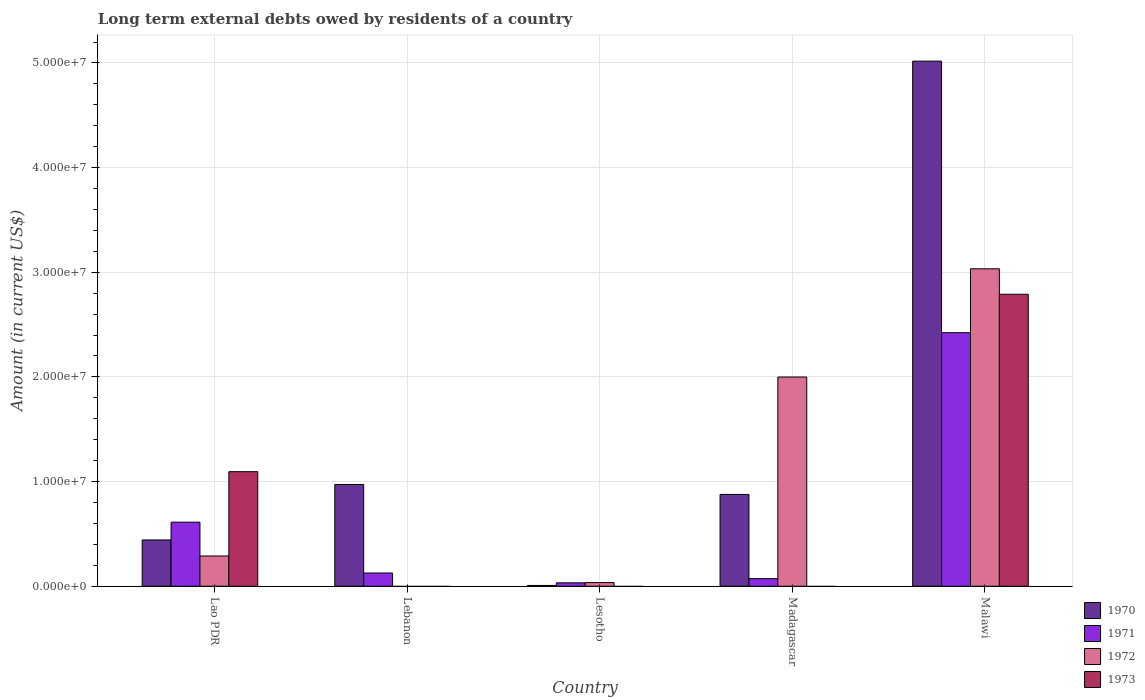How many groups of bars are there?
Your answer should be very brief. 5. Are the number of bars on each tick of the X-axis equal?
Provide a succinct answer. No. How many bars are there on the 2nd tick from the left?
Provide a short and direct response. 2. What is the label of the 1st group of bars from the left?
Your answer should be very brief. Lao PDR. In how many cases, is the number of bars for a given country not equal to the number of legend labels?
Offer a very short reply. 3. What is the amount of long-term external debts owed by residents in 1970 in Malawi?
Your answer should be very brief. 5.02e+07. Across all countries, what is the maximum amount of long-term external debts owed by residents in 1971?
Your answer should be very brief. 2.42e+07. Across all countries, what is the minimum amount of long-term external debts owed by residents in 1971?
Offer a very short reply. 3.26e+05. In which country was the amount of long-term external debts owed by residents in 1971 maximum?
Your answer should be very brief. Malawi. What is the total amount of long-term external debts owed by residents in 1970 in the graph?
Provide a short and direct response. 7.32e+07. What is the difference between the amount of long-term external debts owed by residents in 1973 in Lao PDR and that in Malawi?
Ensure brevity in your answer.  -1.70e+07. What is the difference between the amount of long-term external debts owed by residents in 1970 in Malawi and the amount of long-term external debts owed by residents in 1972 in Lesotho?
Your response must be concise. 4.98e+07. What is the average amount of long-term external debts owed by residents in 1972 per country?
Offer a very short reply. 1.07e+07. What is the difference between the amount of long-term external debts owed by residents of/in 1973 and amount of long-term external debts owed by residents of/in 1972 in Lao PDR?
Provide a short and direct response. 8.06e+06. In how many countries, is the amount of long-term external debts owed by residents in 1972 greater than 28000000 US$?
Your response must be concise. 1. What is the ratio of the amount of long-term external debts owed by residents in 1971 in Lao PDR to that in Lesotho?
Offer a very short reply. 18.79. Is the amount of long-term external debts owed by residents in 1970 in Lesotho less than that in Madagascar?
Provide a short and direct response. Yes. What is the difference between the highest and the second highest amount of long-term external debts owed by residents in 1971?
Offer a very short reply. 2.30e+07. What is the difference between the highest and the lowest amount of long-term external debts owed by residents in 1970?
Ensure brevity in your answer.  5.01e+07. In how many countries, is the amount of long-term external debts owed by residents in 1970 greater than the average amount of long-term external debts owed by residents in 1970 taken over all countries?
Your response must be concise. 1. Is the sum of the amount of long-term external debts owed by residents in 1971 in Lesotho and Madagascar greater than the maximum amount of long-term external debts owed by residents in 1972 across all countries?
Provide a short and direct response. No. Is it the case that in every country, the sum of the amount of long-term external debts owed by residents in 1970 and amount of long-term external debts owed by residents in 1973 is greater than the sum of amount of long-term external debts owed by residents in 1972 and amount of long-term external debts owed by residents in 1971?
Offer a terse response. No. Is it the case that in every country, the sum of the amount of long-term external debts owed by residents in 1972 and amount of long-term external debts owed by residents in 1970 is greater than the amount of long-term external debts owed by residents in 1971?
Make the answer very short. Yes. How many bars are there?
Your answer should be very brief. 16. Are all the bars in the graph horizontal?
Your answer should be very brief. No. Does the graph contain grids?
Your answer should be compact. Yes. Where does the legend appear in the graph?
Make the answer very short. Bottom right. What is the title of the graph?
Your response must be concise. Long term external debts owed by residents of a country. What is the Amount (in current US$) of 1970 in Lao PDR?
Offer a terse response. 4.42e+06. What is the Amount (in current US$) of 1971 in Lao PDR?
Give a very brief answer. 6.12e+06. What is the Amount (in current US$) in 1972 in Lao PDR?
Provide a succinct answer. 2.89e+06. What is the Amount (in current US$) of 1973 in Lao PDR?
Offer a terse response. 1.09e+07. What is the Amount (in current US$) in 1970 in Lebanon?
Give a very brief answer. 9.73e+06. What is the Amount (in current US$) of 1971 in Lebanon?
Provide a succinct answer. 1.26e+06. What is the Amount (in current US$) in 1972 in Lebanon?
Give a very brief answer. 0. What is the Amount (in current US$) in 1973 in Lebanon?
Ensure brevity in your answer.  0. What is the Amount (in current US$) in 1970 in Lesotho?
Ensure brevity in your answer.  7.60e+04. What is the Amount (in current US$) in 1971 in Lesotho?
Provide a short and direct response. 3.26e+05. What is the Amount (in current US$) in 1972 in Lesotho?
Offer a very short reply. 3.48e+05. What is the Amount (in current US$) in 1970 in Madagascar?
Your response must be concise. 8.78e+06. What is the Amount (in current US$) of 1971 in Madagascar?
Your answer should be very brief. 7.30e+05. What is the Amount (in current US$) of 1972 in Madagascar?
Provide a short and direct response. 2.00e+07. What is the Amount (in current US$) in 1973 in Madagascar?
Ensure brevity in your answer.  0. What is the Amount (in current US$) in 1970 in Malawi?
Your answer should be compact. 5.02e+07. What is the Amount (in current US$) in 1971 in Malawi?
Offer a very short reply. 2.42e+07. What is the Amount (in current US$) of 1972 in Malawi?
Keep it short and to the point. 3.03e+07. What is the Amount (in current US$) of 1973 in Malawi?
Your answer should be very brief. 2.79e+07. Across all countries, what is the maximum Amount (in current US$) in 1970?
Give a very brief answer. 5.02e+07. Across all countries, what is the maximum Amount (in current US$) in 1971?
Keep it short and to the point. 2.42e+07. Across all countries, what is the maximum Amount (in current US$) in 1972?
Offer a terse response. 3.03e+07. Across all countries, what is the maximum Amount (in current US$) in 1973?
Provide a succinct answer. 2.79e+07. Across all countries, what is the minimum Amount (in current US$) of 1970?
Make the answer very short. 7.60e+04. Across all countries, what is the minimum Amount (in current US$) in 1971?
Offer a very short reply. 3.26e+05. Across all countries, what is the minimum Amount (in current US$) of 1972?
Ensure brevity in your answer.  0. What is the total Amount (in current US$) of 1970 in the graph?
Give a very brief answer. 7.32e+07. What is the total Amount (in current US$) of 1971 in the graph?
Provide a short and direct response. 3.27e+07. What is the total Amount (in current US$) of 1972 in the graph?
Keep it short and to the point. 5.36e+07. What is the total Amount (in current US$) of 1973 in the graph?
Your answer should be very brief. 3.88e+07. What is the difference between the Amount (in current US$) in 1970 in Lao PDR and that in Lebanon?
Provide a succinct answer. -5.30e+06. What is the difference between the Amount (in current US$) of 1971 in Lao PDR and that in Lebanon?
Offer a very short reply. 4.86e+06. What is the difference between the Amount (in current US$) of 1970 in Lao PDR and that in Lesotho?
Provide a succinct answer. 4.35e+06. What is the difference between the Amount (in current US$) in 1971 in Lao PDR and that in Lesotho?
Keep it short and to the point. 5.80e+06. What is the difference between the Amount (in current US$) in 1972 in Lao PDR and that in Lesotho?
Make the answer very short. 2.54e+06. What is the difference between the Amount (in current US$) in 1970 in Lao PDR and that in Madagascar?
Provide a succinct answer. -4.35e+06. What is the difference between the Amount (in current US$) of 1971 in Lao PDR and that in Madagascar?
Your response must be concise. 5.39e+06. What is the difference between the Amount (in current US$) of 1972 in Lao PDR and that in Madagascar?
Offer a very short reply. -1.71e+07. What is the difference between the Amount (in current US$) in 1970 in Lao PDR and that in Malawi?
Ensure brevity in your answer.  -4.58e+07. What is the difference between the Amount (in current US$) of 1971 in Lao PDR and that in Malawi?
Make the answer very short. -1.81e+07. What is the difference between the Amount (in current US$) of 1972 in Lao PDR and that in Malawi?
Offer a terse response. -2.74e+07. What is the difference between the Amount (in current US$) of 1973 in Lao PDR and that in Malawi?
Your answer should be compact. -1.70e+07. What is the difference between the Amount (in current US$) in 1970 in Lebanon and that in Lesotho?
Keep it short and to the point. 9.65e+06. What is the difference between the Amount (in current US$) of 1971 in Lebanon and that in Lesotho?
Keep it short and to the point. 9.39e+05. What is the difference between the Amount (in current US$) of 1970 in Lebanon and that in Madagascar?
Offer a very short reply. 9.51e+05. What is the difference between the Amount (in current US$) of 1971 in Lebanon and that in Madagascar?
Provide a succinct answer. 5.35e+05. What is the difference between the Amount (in current US$) of 1970 in Lebanon and that in Malawi?
Your response must be concise. -4.04e+07. What is the difference between the Amount (in current US$) of 1971 in Lebanon and that in Malawi?
Your response must be concise. -2.30e+07. What is the difference between the Amount (in current US$) in 1970 in Lesotho and that in Madagascar?
Offer a terse response. -8.70e+06. What is the difference between the Amount (in current US$) of 1971 in Lesotho and that in Madagascar?
Offer a very short reply. -4.04e+05. What is the difference between the Amount (in current US$) of 1972 in Lesotho and that in Madagascar?
Your response must be concise. -1.96e+07. What is the difference between the Amount (in current US$) of 1970 in Lesotho and that in Malawi?
Ensure brevity in your answer.  -5.01e+07. What is the difference between the Amount (in current US$) of 1971 in Lesotho and that in Malawi?
Give a very brief answer. -2.39e+07. What is the difference between the Amount (in current US$) of 1972 in Lesotho and that in Malawi?
Your response must be concise. -3.00e+07. What is the difference between the Amount (in current US$) of 1970 in Madagascar and that in Malawi?
Offer a terse response. -4.14e+07. What is the difference between the Amount (in current US$) of 1971 in Madagascar and that in Malawi?
Give a very brief answer. -2.35e+07. What is the difference between the Amount (in current US$) in 1972 in Madagascar and that in Malawi?
Your answer should be compact. -1.03e+07. What is the difference between the Amount (in current US$) in 1970 in Lao PDR and the Amount (in current US$) in 1971 in Lebanon?
Your response must be concise. 3.16e+06. What is the difference between the Amount (in current US$) in 1970 in Lao PDR and the Amount (in current US$) in 1971 in Lesotho?
Your answer should be very brief. 4.10e+06. What is the difference between the Amount (in current US$) in 1970 in Lao PDR and the Amount (in current US$) in 1972 in Lesotho?
Offer a terse response. 4.08e+06. What is the difference between the Amount (in current US$) of 1971 in Lao PDR and the Amount (in current US$) of 1972 in Lesotho?
Offer a very short reply. 5.78e+06. What is the difference between the Amount (in current US$) in 1970 in Lao PDR and the Amount (in current US$) in 1971 in Madagascar?
Make the answer very short. 3.69e+06. What is the difference between the Amount (in current US$) of 1970 in Lao PDR and the Amount (in current US$) of 1972 in Madagascar?
Offer a very short reply. -1.56e+07. What is the difference between the Amount (in current US$) of 1971 in Lao PDR and the Amount (in current US$) of 1972 in Madagascar?
Your response must be concise. -1.39e+07. What is the difference between the Amount (in current US$) in 1970 in Lao PDR and the Amount (in current US$) in 1971 in Malawi?
Make the answer very short. -1.98e+07. What is the difference between the Amount (in current US$) of 1970 in Lao PDR and the Amount (in current US$) of 1972 in Malawi?
Offer a terse response. -2.59e+07. What is the difference between the Amount (in current US$) in 1970 in Lao PDR and the Amount (in current US$) in 1973 in Malawi?
Your response must be concise. -2.35e+07. What is the difference between the Amount (in current US$) of 1971 in Lao PDR and the Amount (in current US$) of 1972 in Malawi?
Your answer should be very brief. -2.42e+07. What is the difference between the Amount (in current US$) in 1971 in Lao PDR and the Amount (in current US$) in 1973 in Malawi?
Ensure brevity in your answer.  -2.18e+07. What is the difference between the Amount (in current US$) of 1972 in Lao PDR and the Amount (in current US$) of 1973 in Malawi?
Provide a succinct answer. -2.50e+07. What is the difference between the Amount (in current US$) in 1970 in Lebanon and the Amount (in current US$) in 1971 in Lesotho?
Provide a succinct answer. 9.40e+06. What is the difference between the Amount (in current US$) in 1970 in Lebanon and the Amount (in current US$) in 1972 in Lesotho?
Offer a very short reply. 9.38e+06. What is the difference between the Amount (in current US$) of 1971 in Lebanon and the Amount (in current US$) of 1972 in Lesotho?
Offer a terse response. 9.17e+05. What is the difference between the Amount (in current US$) in 1970 in Lebanon and the Amount (in current US$) in 1971 in Madagascar?
Keep it short and to the point. 9.00e+06. What is the difference between the Amount (in current US$) in 1970 in Lebanon and the Amount (in current US$) in 1972 in Madagascar?
Keep it short and to the point. -1.03e+07. What is the difference between the Amount (in current US$) in 1971 in Lebanon and the Amount (in current US$) in 1972 in Madagascar?
Make the answer very short. -1.87e+07. What is the difference between the Amount (in current US$) in 1970 in Lebanon and the Amount (in current US$) in 1971 in Malawi?
Provide a succinct answer. -1.45e+07. What is the difference between the Amount (in current US$) of 1970 in Lebanon and the Amount (in current US$) of 1972 in Malawi?
Ensure brevity in your answer.  -2.06e+07. What is the difference between the Amount (in current US$) in 1970 in Lebanon and the Amount (in current US$) in 1973 in Malawi?
Offer a very short reply. -1.82e+07. What is the difference between the Amount (in current US$) in 1971 in Lebanon and the Amount (in current US$) in 1972 in Malawi?
Give a very brief answer. -2.91e+07. What is the difference between the Amount (in current US$) in 1971 in Lebanon and the Amount (in current US$) in 1973 in Malawi?
Keep it short and to the point. -2.66e+07. What is the difference between the Amount (in current US$) in 1970 in Lesotho and the Amount (in current US$) in 1971 in Madagascar?
Your response must be concise. -6.54e+05. What is the difference between the Amount (in current US$) in 1970 in Lesotho and the Amount (in current US$) in 1972 in Madagascar?
Provide a short and direct response. -1.99e+07. What is the difference between the Amount (in current US$) in 1971 in Lesotho and the Amount (in current US$) in 1972 in Madagascar?
Your response must be concise. -1.97e+07. What is the difference between the Amount (in current US$) in 1970 in Lesotho and the Amount (in current US$) in 1971 in Malawi?
Make the answer very short. -2.42e+07. What is the difference between the Amount (in current US$) in 1970 in Lesotho and the Amount (in current US$) in 1972 in Malawi?
Ensure brevity in your answer.  -3.03e+07. What is the difference between the Amount (in current US$) in 1970 in Lesotho and the Amount (in current US$) in 1973 in Malawi?
Offer a very short reply. -2.78e+07. What is the difference between the Amount (in current US$) of 1971 in Lesotho and the Amount (in current US$) of 1972 in Malawi?
Give a very brief answer. -3.00e+07. What is the difference between the Amount (in current US$) in 1971 in Lesotho and the Amount (in current US$) in 1973 in Malawi?
Provide a short and direct response. -2.76e+07. What is the difference between the Amount (in current US$) of 1972 in Lesotho and the Amount (in current US$) of 1973 in Malawi?
Ensure brevity in your answer.  -2.76e+07. What is the difference between the Amount (in current US$) of 1970 in Madagascar and the Amount (in current US$) of 1971 in Malawi?
Your answer should be compact. -1.55e+07. What is the difference between the Amount (in current US$) of 1970 in Madagascar and the Amount (in current US$) of 1972 in Malawi?
Your answer should be compact. -2.16e+07. What is the difference between the Amount (in current US$) in 1970 in Madagascar and the Amount (in current US$) in 1973 in Malawi?
Provide a succinct answer. -1.91e+07. What is the difference between the Amount (in current US$) of 1971 in Madagascar and the Amount (in current US$) of 1972 in Malawi?
Your answer should be compact. -2.96e+07. What is the difference between the Amount (in current US$) of 1971 in Madagascar and the Amount (in current US$) of 1973 in Malawi?
Your answer should be very brief. -2.72e+07. What is the difference between the Amount (in current US$) of 1972 in Madagascar and the Amount (in current US$) of 1973 in Malawi?
Offer a terse response. -7.91e+06. What is the average Amount (in current US$) in 1970 per country?
Offer a terse response. 1.46e+07. What is the average Amount (in current US$) in 1971 per country?
Provide a succinct answer. 6.53e+06. What is the average Amount (in current US$) in 1972 per country?
Your answer should be very brief. 1.07e+07. What is the average Amount (in current US$) in 1973 per country?
Your answer should be compact. 7.77e+06. What is the difference between the Amount (in current US$) of 1970 and Amount (in current US$) of 1971 in Lao PDR?
Provide a succinct answer. -1.70e+06. What is the difference between the Amount (in current US$) of 1970 and Amount (in current US$) of 1972 in Lao PDR?
Offer a terse response. 1.53e+06. What is the difference between the Amount (in current US$) of 1970 and Amount (in current US$) of 1973 in Lao PDR?
Your answer should be very brief. -6.52e+06. What is the difference between the Amount (in current US$) in 1971 and Amount (in current US$) in 1972 in Lao PDR?
Your response must be concise. 3.23e+06. What is the difference between the Amount (in current US$) of 1971 and Amount (in current US$) of 1973 in Lao PDR?
Provide a succinct answer. -4.82e+06. What is the difference between the Amount (in current US$) in 1972 and Amount (in current US$) in 1973 in Lao PDR?
Ensure brevity in your answer.  -8.06e+06. What is the difference between the Amount (in current US$) in 1970 and Amount (in current US$) in 1971 in Lebanon?
Offer a terse response. 8.46e+06. What is the difference between the Amount (in current US$) of 1970 and Amount (in current US$) of 1971 in Lesotho?
Give a very brief answer. -2.50e+05. What is the difference between the Amount (in current US$) of 1970 and Amount (in current US$) of 1972 in Lesotho?
Your response must be concise. -2.72e+05. What is the difference between the Amount (in current US$) in 1971 and Amount (in current US$) in 1972 in Lesotho?
Provide a succinct answer. -2.20e+04. What is the difference between the Amount (in current US$) of 1970 and Amount (in current US$) of 1971 in Madagascar?
Your answer should be compact. 8.04e+06. What is the difference between the Amount (in current US$) of 1970 and Amount (in current US$) of 1972 in Madagascar?
Provide a succinct answer. -1.12e+07. What is the difference between the Amount (in current US$) of 1971 and Amount (in current US$) of 1972 in Madagascar?
Your answer should be very brief. -1.93e+07. What is the difference between the Amount (in current US$) in 1970 and Amount (in current US$) in 1971 in Malawi?
Ensure brevity in your answer.  2.59e+07. What is the difference between the Amount (in current US$) in 1970 and Amount (in current US$) in 1972 in Malawi?
Your response must be concise. 1.98e+07. What is the difference between the Amount (in current US$) in 1970 and Amount (in current US$) in 1973 in Malawi?
Provide a succinct answer. 2.23e+07. What is the difference between the Amount (in current US$) in 1971 and Amount (in current US$) in 1972 in Malawi?
Your response must be concise. -6.11e+06. What is the difference between the Amount (in current US$) in 1971 and Amount (in current US$) in 1973 in Malawi?
Offer a very short reply. -3.67e+06. What is the difference between the Amount (in current US$) of 1972 and Amount (in current US$) of 1973 in Malawi?
Keep it short and to the point. 2.43e+06. What is the ratio of the Amount (in current US$) of 1970 in Lao PDR to that in Lebanon?
Your answer should be compact. 0.45. What is the ratio of the Amount (in current US$) in 1971 in Lao PDR to that in Lebanon?
Make the answer very short. 4.84. What is the ratio of the Amount (in current US$) in 1970 in Lao PDR to that in Lesotho?
Your response must be concise. 58.21. What is the ratio of the Amount (in current US$) in 1971 in Lao PDR to that in Lesotho?
Give a very brief answer. 18.79. What is the ratio of the Amount (in current US$) in 1972 in Lao PDR to that in Lesotho?
Provide a short and direct response. 8.31. What is the ratio of the Amount (in current US$) of 1970 in Lao PDR to that in Madagascar?
Provide a succinct answer. 0.5. What is the ratio of the Amount (in current US$) in 1971 in Lao PDR to that in Madagascar?
Ensure brevity in your answer.  8.39. What is the ratio of the Amount (in current US$) of 1972 in Lao PDR to that in Madagascar?
Ensure brevity in your answer.  0.14. What is the ratio of the Amount (in current US$) in 1970 in Lao PDR to that in Malawi?
Make the answer very short. 0.09. What is the ratio of the Amount (in current US$) of 1971 in Lao PDR to that in Malawi?
Your answer should be very brief. 0.25. What is the ratio of the Amount (in current US$) of 1972 in Lao PDR to that in Malawi?
Offer a terse response. 0.1. What is the ratio of the Amount (in current US$) of 1973 in Lao PDR to that in Malawi?
Offer a terse response. 0.39. What is the ratio of the Amount (in current US$) of 1970 in Lebanon to that in Lesotho?
Provide a short and direct response. 127.97. What is the ratio of the Amount (in current US$) in 1971 in Lebanon to that in Lesotho?
Offer a terse response. 3.88. What is the ratio of the Amount (in current US$) in 1970 in Lebanon to that in Madagascar?
Ensure brevity in your answer.  1.11. What is the ratio of the Amount (in current US$) of 1971 in Lebanon to that in Madagascar?
Your response must be concise. 1.73. What is the ratio of the Amount (in current US$) of 1970 in Lebanon to that in Malawi?
Offer a terse response. 0.19. What is the ratio of the Amount (in current US$) of 1971 in Lebanon to that in Malawi?
Offer a very short reply. 0.05. What is the ratio of the Amount (in current US$) in 1970 in Lesotho to that in Madagascar?
Your response must be concise. 0.01. What is the ratio of the Amount (in current US$) in 1971 in Lesotho to that in Madagascar?
Offer a terse response. 0.45. What is the ratio of the Amount (in current US$) in 1972 in Lesotho to that in Madagascar?
Your answer should be compact. 0.02. What is the ratio of the Amount (in current US$) in 1970 in Lesotho to that in Malawi?
Your answer should be very brief. 0. What is the ratio of the Amount (in current US$) in 1971 in Lesotho to that in Malawi?
Make the answer very short. 0.01. What is the ratio of the Amount (in current US$) in 1972 in Lesotho to that in Malawi?
Ensure brevity in your answer.  0.01. What is the ratio of the Amount (in current US$) of 1970 in Madagascar to that in Malawi?
Keep it short and to the point. 0.17. What is the ratio of the Amount (in current US$) in 1971 in Madagascar to that in Malawi?
Make the answer very short. 0.03. What is the ratio of the Amount (in current US$) in 1972 in Madagascar to that in Malawi?
Offer a very short reply. 0.66. What is the difference between the highest and the second highest Amount (in current US$) of 1970?
Ensure brevity in your answer.  4.04e+07. What is the difference between the highest and the second highest Amount (in current US$) in 1971?
Keep it short and to the point. 1.81e+07. What is the difference between the highest and the second highest Amount (in current US$) in 1972?
Offer a terse response. 1.03e+07. What is the difference between the highest and the lowest Amount (in current US$) in 1970?
Make the answer very short. 5.01e+07. What is the difference between the highest and the lowest Amount (in current US$) of 1971?
Offer a very short reply. 2.39e+07. What is the difference between the highest and the lowest Amount (in current US$) in 1972?
Your answer should be very brief. 3.03e+07. What is the difference between the highest and the lowest Amount (in current US$) in 1973?
Provide a short and direct response. 2.79e+07. 